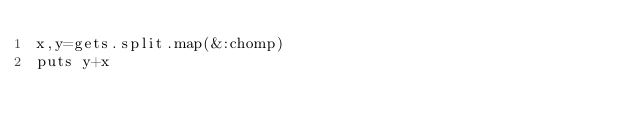Convert code to text. <code><loc_0><loc_0><loc_500><loc_500><_Ruby_>x,y=gets.split.map(&:chomp)
puts y+x
</code> 